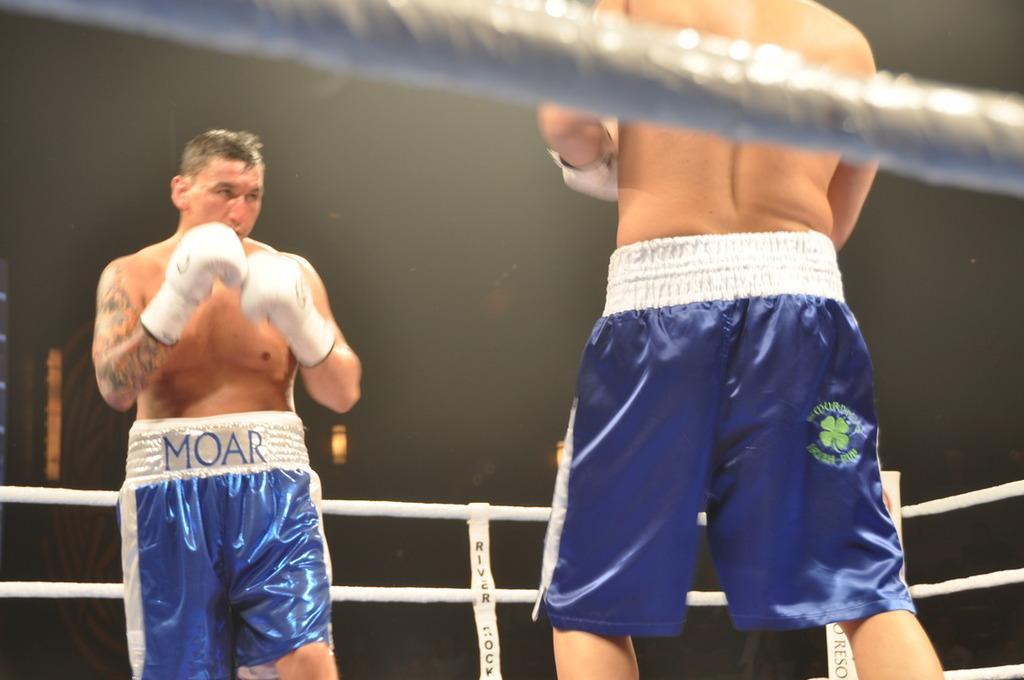Can you describe this image briefly? There are two boxers boxing inside the stage there is a fencing around them,both of them are wearing blue shorts and white gloves. 